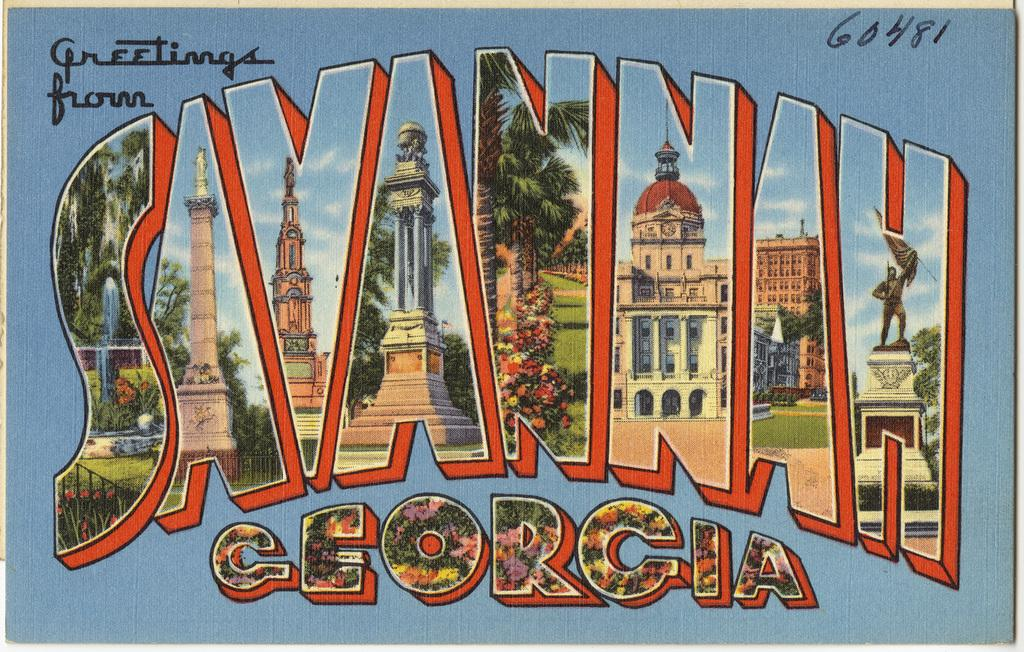What type of visual is the image? The image is a poster. What type of structures are depicted on the poster? There are buildings depicted on the poster. What type of natural elements are depicted on the poster? There are trees depicted on the poster. What type of atmospheric conditions are depicted on the poster? The sky with clouds is depicted on the poster. What type of written content is present on the poster? There is some text present on the poster. What type of zipper can be seen on the buildings depicted on the poster? There is no zipper present on the buildings depicted on the poster. How many stars are visible in the sky depicted on the poster? The poster does not depict any stars in the sky. 